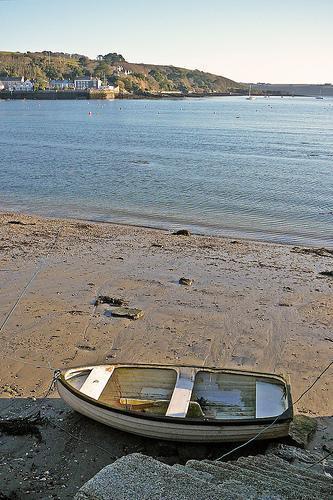How many boats are there?
Give a very brief answer. 1. 